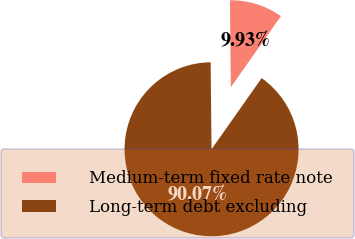<chart> <loc_0><loc_0><loc_500><loc_500><pie_chart><fcel>Medium-term fixed rate note<fcel>Long-term debt excluding<nl><fcel>9.93%<fcel>90.07%<nl></chart> 